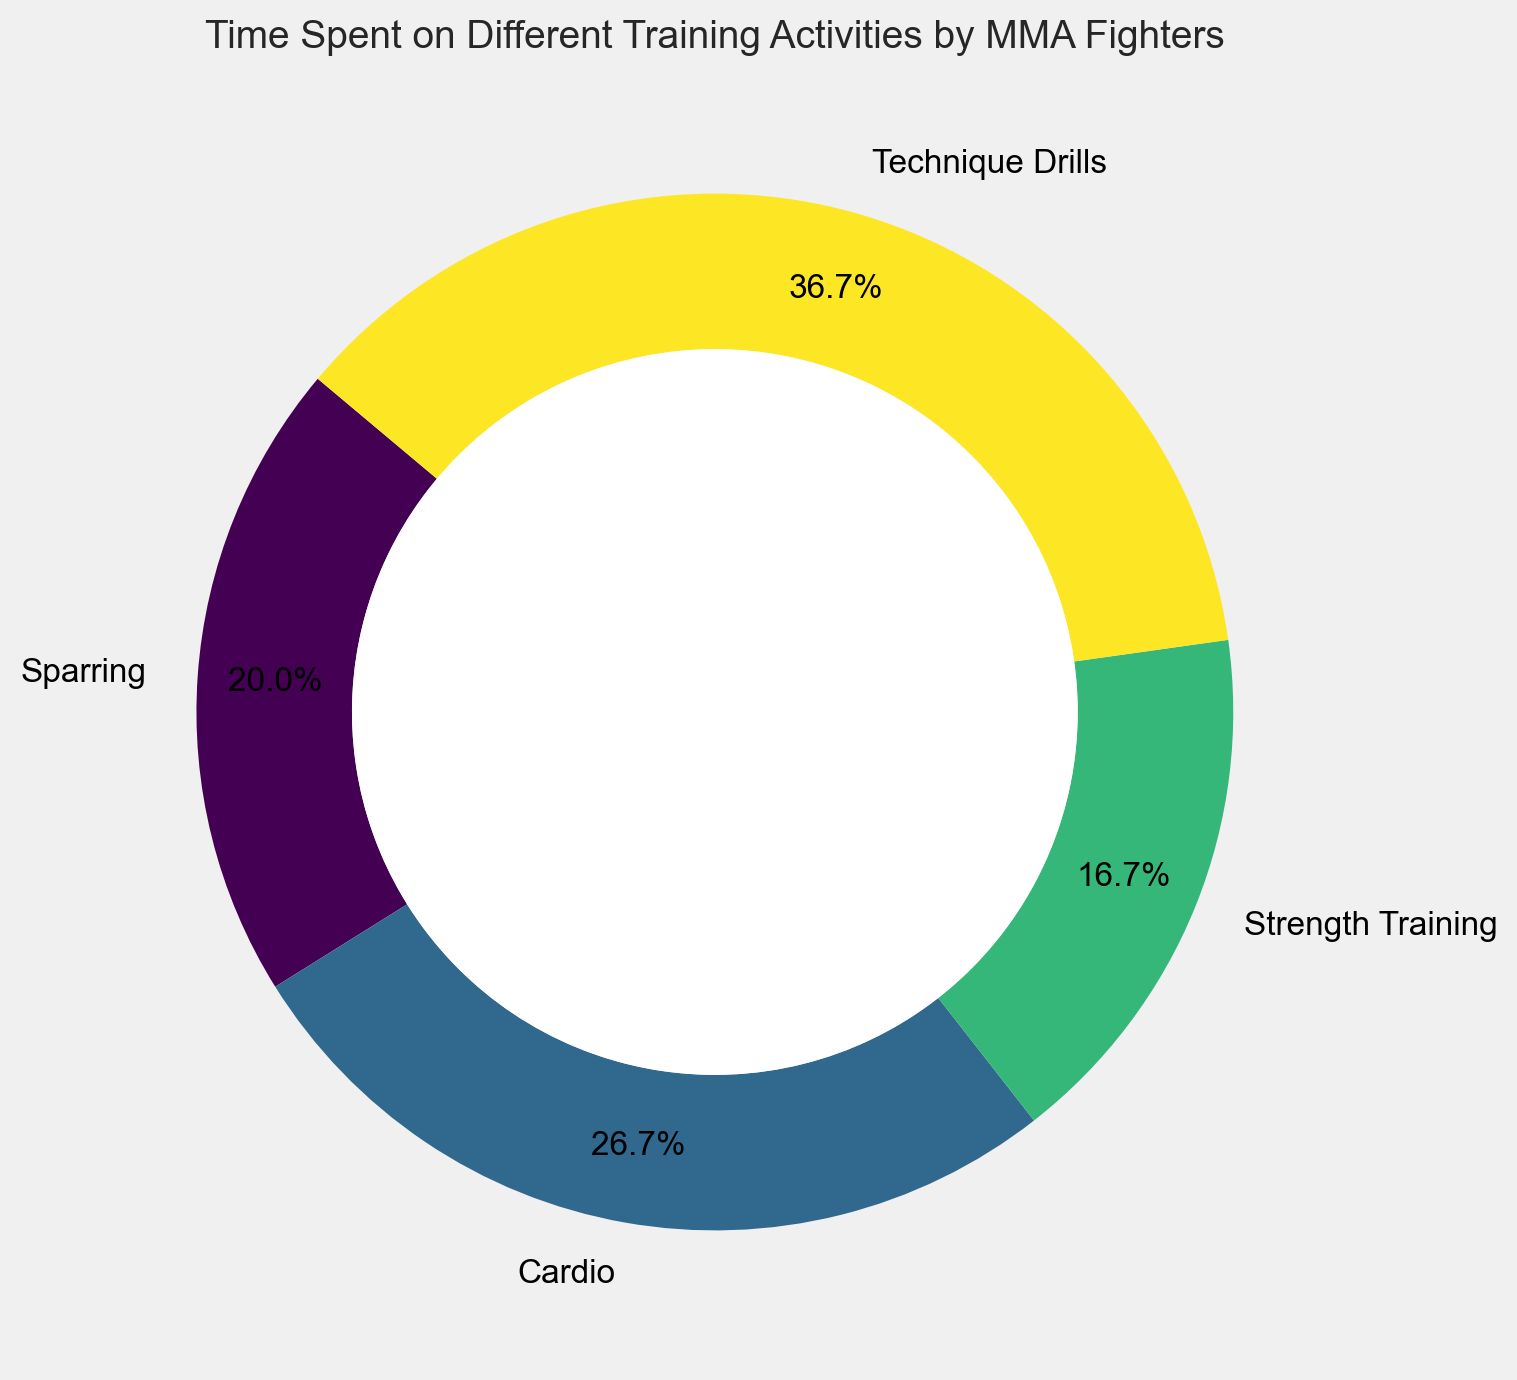Which training activity takes up the most time for MMA fighters? By looking at the pie chart, we identify the activity that has the largest segment or the highest percentage displayed.
Answer: Technique Drills What percentage of time do MMA fighters spend on Cardio? By locating the Cardio segment and reading the percentage label attached to it on the pie chart.
Answer: 32% How much more time do MMA fighters spend on Technique Drills compared to Sparring per week? Find the weekly hours dedicated to both activities: Technique Drills is 11 hours, and Sparring is 6 hours. Subtract the time spent on Sparring from the time spent on Technique Drills.
Answer: 5 hours What is the combined percentage of time spent on Strength Training and Sparring? Locate the percentages for Strength Training and Sparring on the pie chart (20% and 24%, respectively), and add them together.
Answer: 44% Is the time spent on Cardio greater than the combined time spent on Strength Training and Sparring? Compare the percentage of Cardio (32%) against the combined percentage of Strength Training (20%) and Sparring (24%). 32% is less than 44%.
Answer: No Which segment of the pie chart is represented in green? The color palette used in the pie chart can visually indicate that the green segment corresponds to Cardio.
Answer: Cardio If a fighter decides to reduce the time spent on Technique Drills by 3 hours and increase Sparring by the same amount, what would the new time distribution look like in hours per week for these two activities? Original hours: Technique Drills = 11, Sparring = 6. New hours: Technique Drills = 11 - 3 = 8, Sparring = 6 + 3 = 9
Answer: Technique Drills: 8, Sparring: 9 How much time in total do MMA fighters spend on training activities per week? Sum up the weekly hours dedicated to all activities: 6 (Sparring) + 8 (Cardio) + 5 (Strength Training) + 11 (Technique Drills).
Answer: 30 hours 